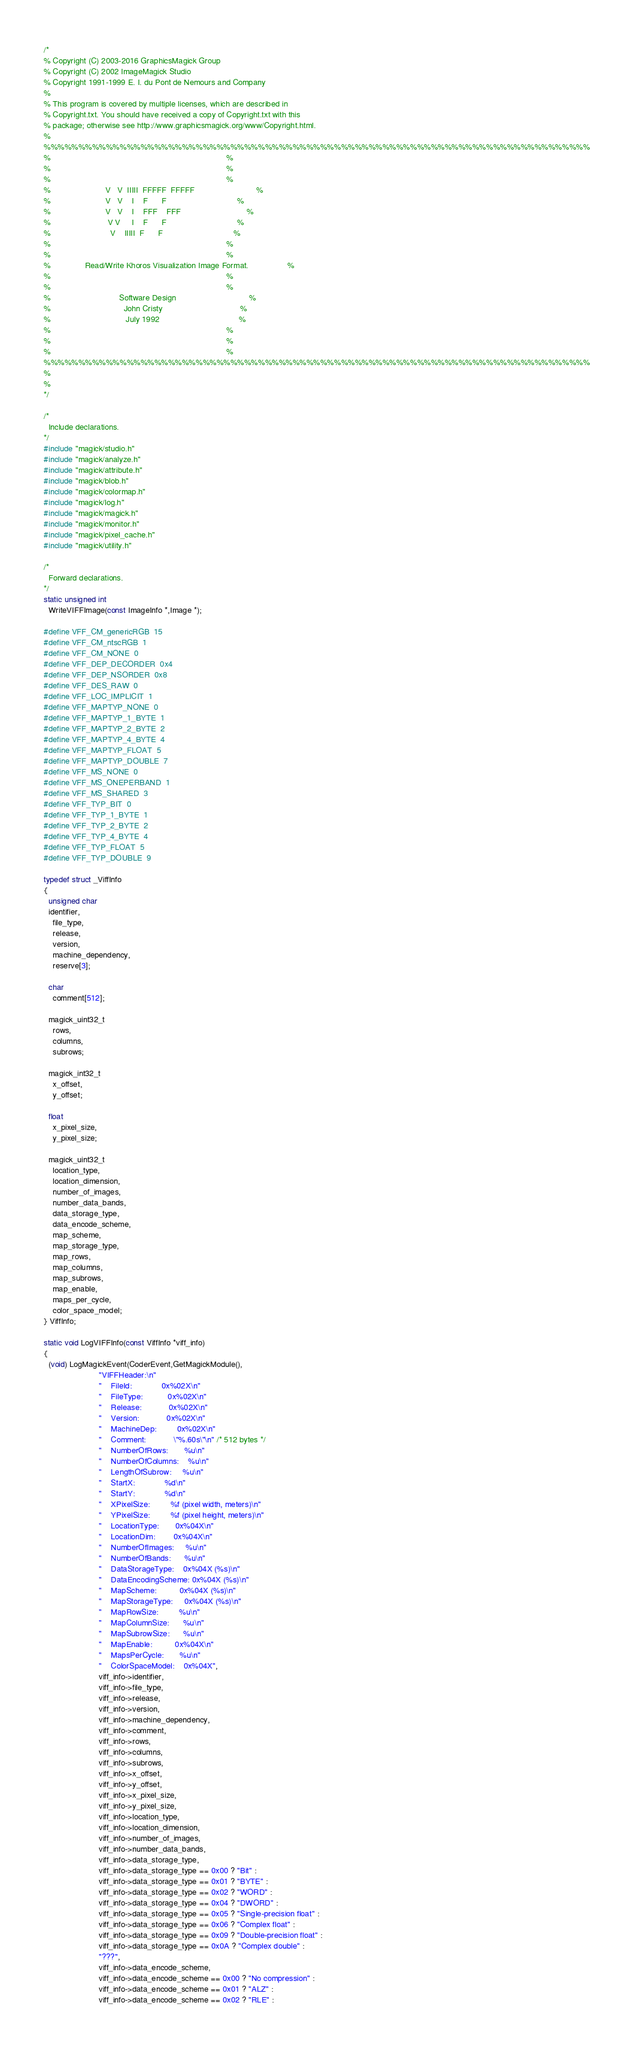Convert code to text. <code><loc_0><loc_0><loc_500><loc_500><_C_>/*
% Copyright (C) 2003-2016 GraphicsMagick Group
% Copyright (C) 2002 ImageMagick Studio
% Copyright 1991-1999 E. I. du Pont de Nemours and Company
%
% This program is covered by multiple licenses, which are described in
% Copyright.txt. You should have received a copy of Copyright.txt with this
% package; otherwise see http://www.graphicsmagick.org/www/Copyright.html.
%
%%%%%%%%%%%%%%%%%%%%%%%%%%%%%%%%%%%%%%%%%%%%%%%%%%%%%%%%%%%%%%%%%%%%%%%%%%%%%%%
%                                                                             %
%                                                                             %
%                                                                             %
%                        V   V  IIIII  FFFFF  FFFFF                           %
%                        V   V    I    F      F                               %
%                        V   V    I    FFF    FFF                             %
%                         V V     I    F      F                               %
%                          V    IIIII  F      F                               %
%                                                                             %
%                                                                             %
%               Read/Write Khoros Visualization Image Format.                 %
%                                                                             %
%                                                                             %
%                              Software Design                                %
%                                John Cristy                                  %
%                                 July 1992                                   %
%                                                                             %
%                                                                             %
%                                                                             %
%%%%%%%%%%%%%%%%%%%%%%%%%%%%%%%%%%%%%%%%%%%%%%%%%%%%%%%%%%%%%%%%%%%%%%%%%%%%%%%
%
%
*/

/*
  Include declarations.
*/
#include "magick/studio.h"
#include "magick/analyze.h"
#include "magick/attribute.h"
#include "magick/blob.h"
#include "magick/colormap.h"
#include "magick/log.h"
#include "magick/magick.h"
#include "magick/monitor.h"
#include "magick/pixel_cache.h"
#include "magick/utility.h"

/*
  Forward declarations.
*/
static unsigned int
  WriteVIFFImage(const ImageInfo *,Image *);

#define VFF_CM_genericRGB  15
#define VFF_CM_ntscRGB  1
#define VFF_CM_NONE  0
#define VFF_DEP_DECORDER  0x4
#define VFF_DEP_NSORDER  0x8
#define VFF_DES_RAW  0
#define VFF_LOC_IMPLICIT  1
#define VFF_MAPTYP_NONE  0
#define VFF_MAPTYP_1_BYTE  1
#define VFF_MAPTYP_2_BYTE  2
#define VFF_MAPTYP_4_BYTE  4
#define VFF_MAPTYP_FLOAT  5
#define VFF_MAPTYP_DOUBLE  7
#define VFF_MS_NONE  0
#define VFF_MS_ONEPERBAND  1
#define VFF_MS_SHARED  3
#define VFF_TYP_BIT  0
#define VFF_TYP_1_BYTE  1
#define VFF_TYP_2_BYTE  2
#define VFF_TYP_4_BYTE  4
#define VFF_TYP_FLOAT  5
#define VFF_TYP_DOUBLE  9

typedef struct _ViffInfo
{
  unsigned char
  identifier,
    file_type,
    release,
    version,
    machine_dependency,
    reserve[3];

  char
    comment[512];

  magick_uint32_t
    rows,
    columns,
    subrows;

  magick_int32_t
    x_offset,
    y_offset;

  float
    x_pixel_size,
    y_pixel_size;

  magick_uint32_t
    location_type,
    location_dimension,
    number_of_images,
    number_data_bands,
    data_storage_type,
    data_encode_scheme,
    map_scheme,
    map_storage_type,
    map_rows,
    map_columns,
    map_subrows,
    map_enable,
    maps_per_cycle,
    color_space_model;
} ViffInfo;

static void LogVIFFInfo(const ViffInfo *viff_info)
{
  (void) LogMagickEvent(CoderEvent,GetMagickModule(),
                        "VIFFHeader:\n"
                        "    FileId:             0x%02X\n"
                        "    FileType:           0x%02X\n"
                        "    Release:            0x%02X\n"
                        "    Version:            0x%02X\n"
                        "    MachineDep:         0x%02X\n"
                        "    Comment:            \"%.60s\"\n" /* 512 bytes */
                        "    NumberOfRows:       %u\n"
                        "    NumberOfColumns:    %u\n"
                        "    LengthOfSubrow:     %u\n"
                        "    StartX:             %d\n"
                        "    StartY:             %d\n"
                        "    XPixelSize:         %f (pixel width, meters)\n"
                        "    YPixelSize:         %f (pixel height, meters)\n"
                        "    LocationType:       0x%04X\n"
                        "    LocationDim:        0x%04X\n"
                        "    NumberOfImages:     %u\n"
                        "    NumberOfBands:      %u\n"
                        "    DataStorageType:    0x%04X (%s)\n"
                        "    DataEncodingScheme: 0x%04X (%s)\n"
                        "    MapScheme:          0x%04X (%s)\n"
                        "    MapStorageType:     0x%04X (%s)\n"
                        "    MapRowSize:         %u\n"
                        "    MapColumnSize:      %u\n"
                        "    MapSubrowSize:      %u\n"
                        "    MapEnable:          0x%04X\n"
                        "    MapsPerCycle:       %u\n"
                        "    ColorSpaceModel:    0x%04X",
                        viff_info->identifier,
                        viff_info->file_type,
                        viff_info->release,
                        viff_info->version,
                        viff_info->machine_dependency,
                        viff_info->comment,
                        viff_info->rows,
                        viff_info->columns,
                        viff_info->subrows,
                        viff_info->x_offset,
                        viff_info->y_offset,
                        viff_info->x_pixel_size,
                        viff_info->y_pixel_size,
                        viff_info->location_type,
                        viff_info->location_dimension,
                        viff_info->number_of_images,
                        viff_info->number_data_bands,
                        viff_info->data_storage_type,
                        viff_info->data_storage_type == 0x00 ? "Bit" :
                        viff_info->data_storage_type == 0x01 ? "BYTE" :
                        viff_info->data_storage_type == 0x02 ? "WORD" :
                        viff_info->data_storage_type == 0x04 ? "DWORD" :
                        viff_info->data_storage_type == 0x05 ? "Single-precision float" :
                        viff_info->data_storage_type == 0x06 ? "Complex float" :
                        viff_info->data_storage_type == 0x09 ? "Double-precision float" :
                        viff_info->data_storage_type == 0x0A ? "Complex double" :
                        "???",
                        viff_info->data_encode_scheme,
                        viff_info->data_encode_scheme == 0x00 ? "No compression" :
                        viff_info->data_encode_scheme == 0x01 ? "ALZ" :
                        viff_info->data_encode_scheme == 0x02 ? "RLE" :</code> 